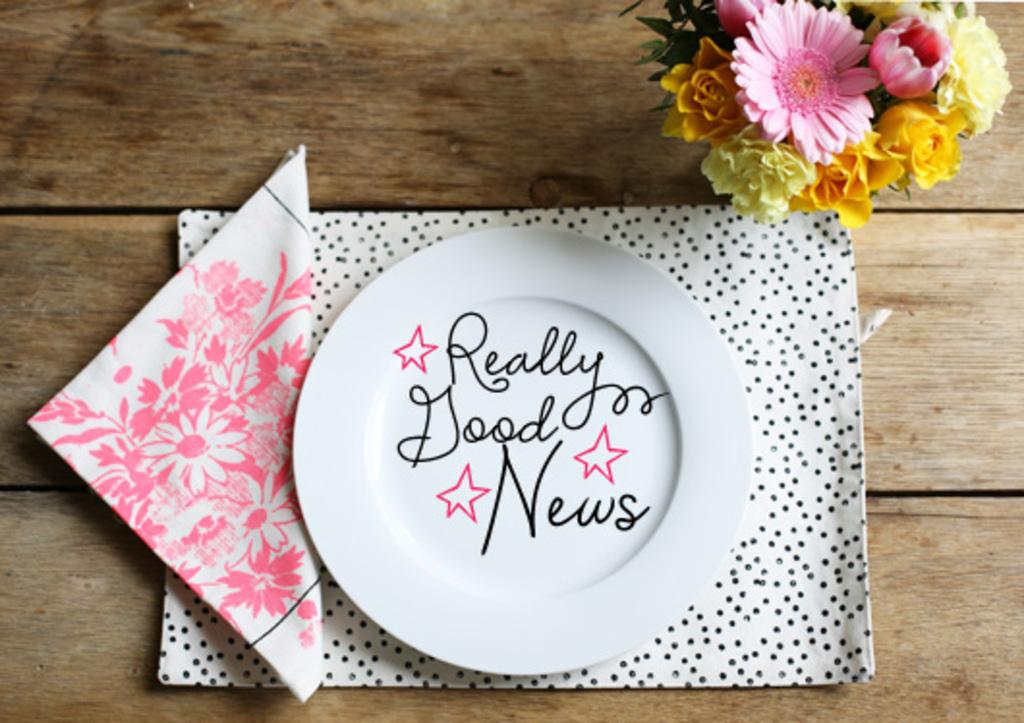<image>
Render a clear and concise summary of the photo. a white plate that says Really Good News on it 